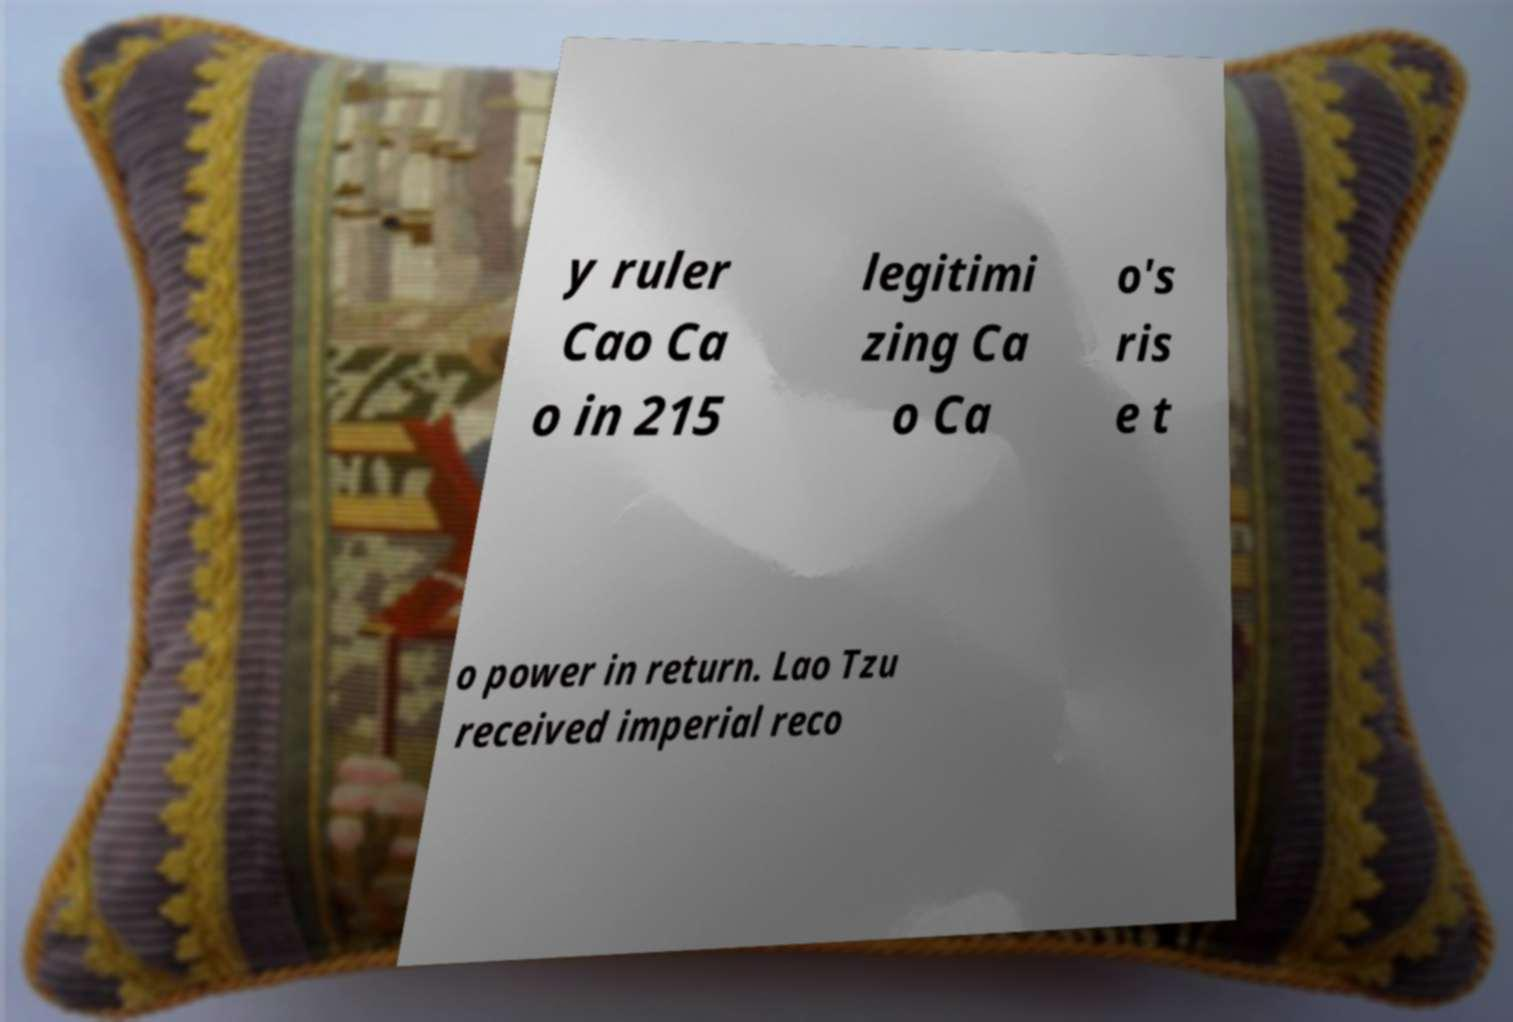Can you read and provide the text displayed in the image?This photo seems to have some interesting text. Can you extract and type it out for me? y ruler Cao Ca o in 215 legitimi zing Ca o Ca o's ris e t o power in return. Lao Tzu received imperial reco 